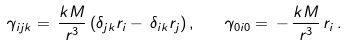<formula> <loc_0><loc_0><loc_500><loc_500>\gamma _ { i j k } = \, \frac { k M } { r ^ { 3 } } \, ( \delta _ { j k } r _ { i } - \, \delta _ { i k } r _ { j } ) \, , \quad \gamma _ { 0 i 0 } = \, - \, \frac { k M } { r ^ { 3 } } \, r _ { i } \, .</formula> 